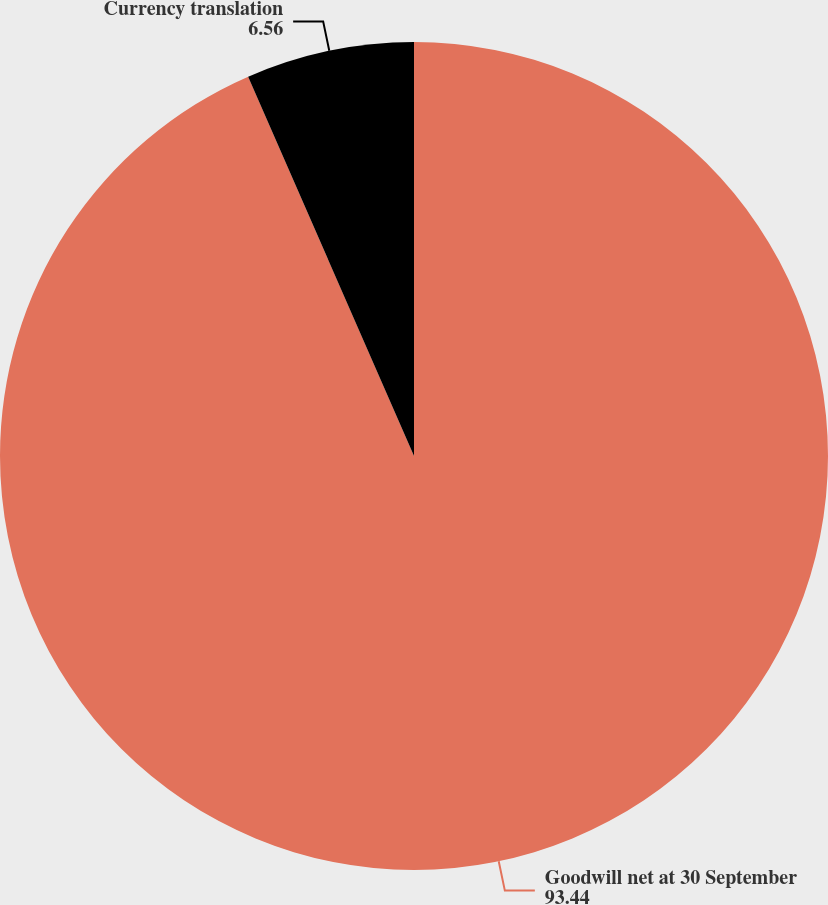<chart> <loc_0><loc_0><loc_500><loc_500><pie_chart><fcel>Goodwill net at 30 September<fcel>Currency translation<nl><fcel>93.44%<fcel>6.56%<nl></chart> 